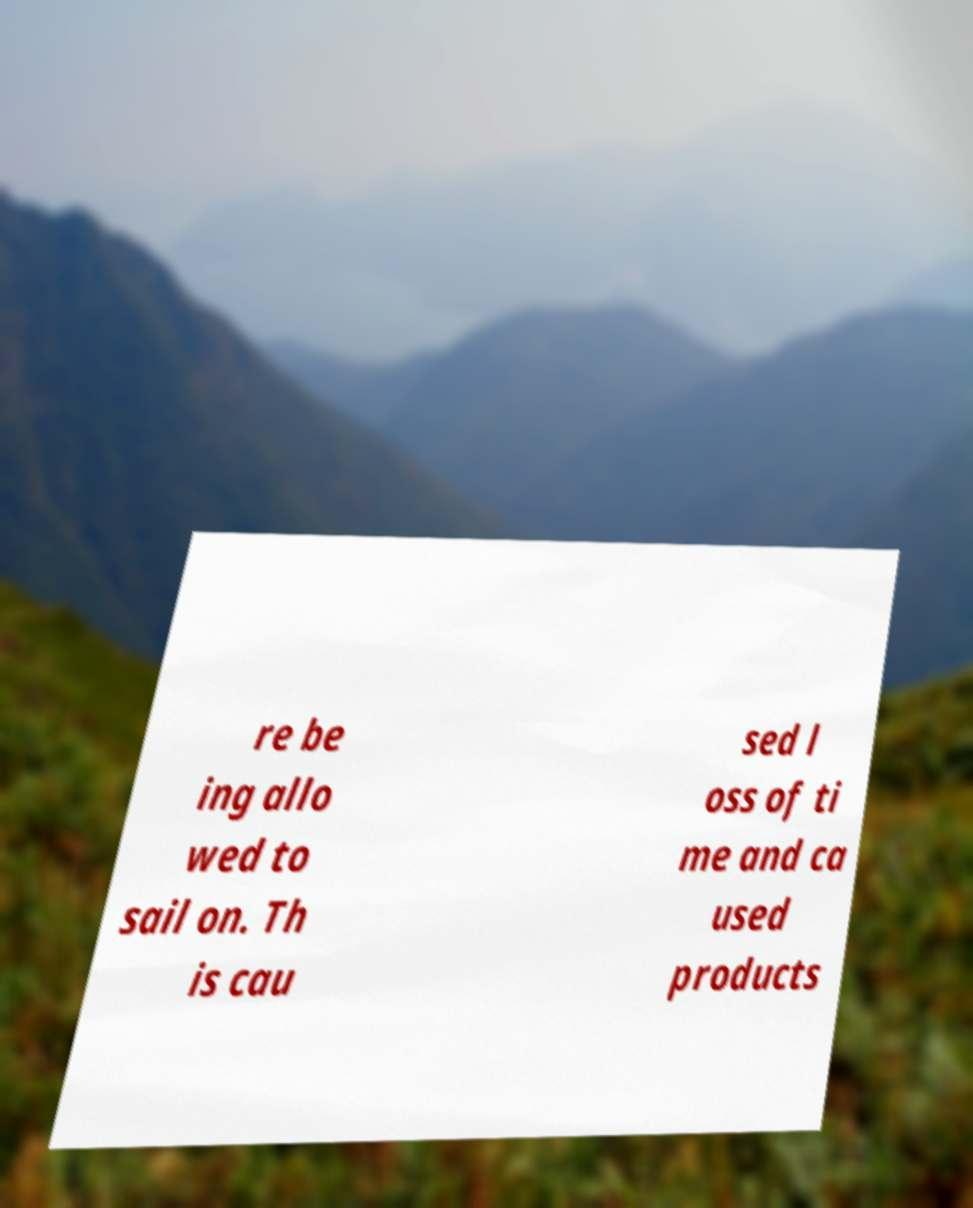Can you accurately transcribe the text from the provided image for me? re be ing allo wed to sail on. Th is cau sed l oss of ti me and ca used products 